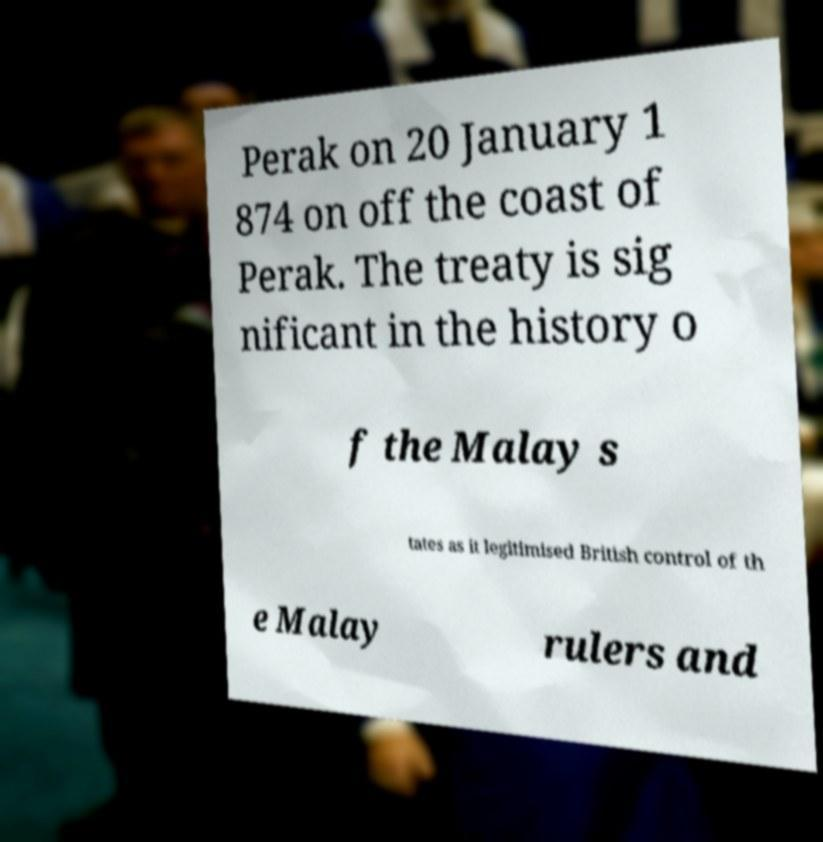Could you extract and type out the text from this image? Perak on 20 January 1 874 on off the coast of Perak. The treaty is sig nificant in the history o f the Malay s tates as it legitimised British control of th e Malay rulers and 